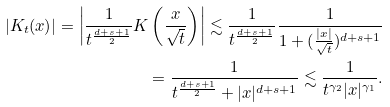<formula> <loc_0><loc_0><loc_500><loc_500>| K _ { t } ( x ) | = \left | \frac { 1 } { t ^ { \frac { d + s + 1 } { 2 } } } K \left ( \frac { x } { \sqrt { t } } \right ) \right | \lesssim \frac { 1 } { t ^ { \frac { d + s + 1 } { 2 } } } \frac { 1 } { 1 + ( \frac { | x | } { \sqrt { t } } ) ^ { d + s + 1 } } \\ = \frac { 1 } { t ^ { \frac { d + s + 1 } { 2 } } + | x | ^ { d + s + 1 } } \lesssim \frac { 1 } { { t } ^ { \gamma _ { 2 } } | x | ^ { \gamma _ { 1 } } } .</formula> 